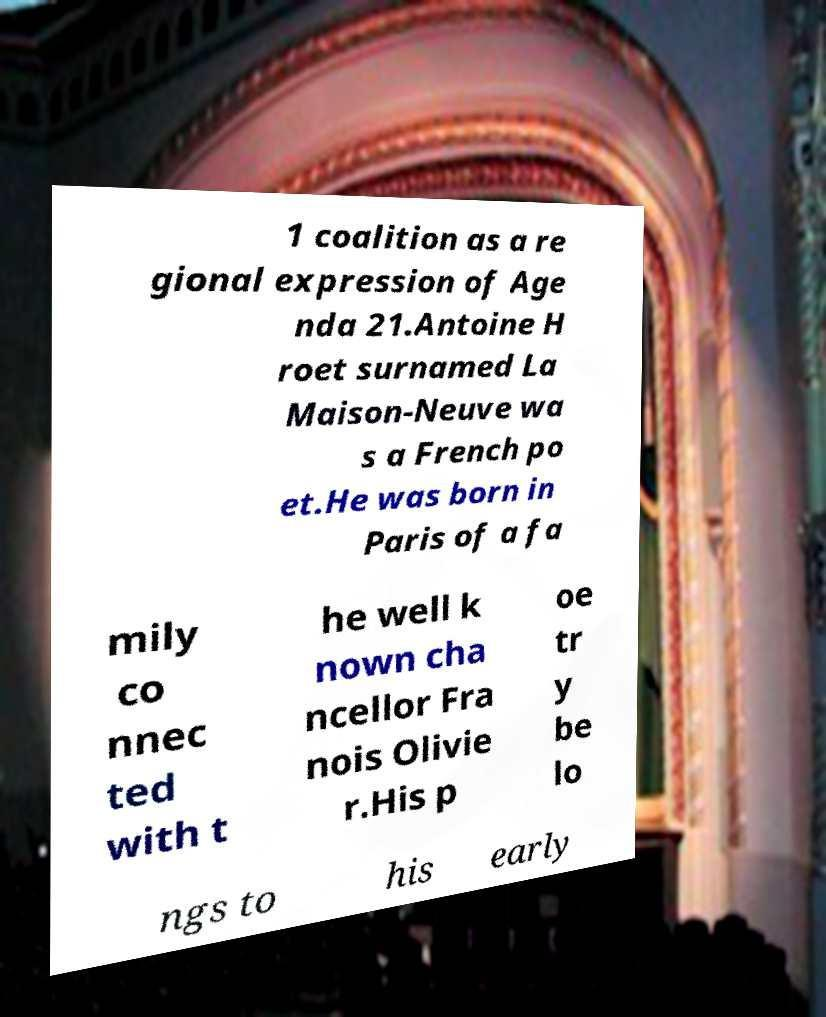For documentation purposes, I need the text within this image transcribed. Could you provide that? 1 coalition as a re gional expression of Age nda 21.Antoine H roet surnamed La Maison-Neuve wa s a French po et.He was born in Paris of a fa mily co nnec ted with t he well k nown cha ncellor Fra nois Olivie r.His p oe tr y be lo ngs to his early 